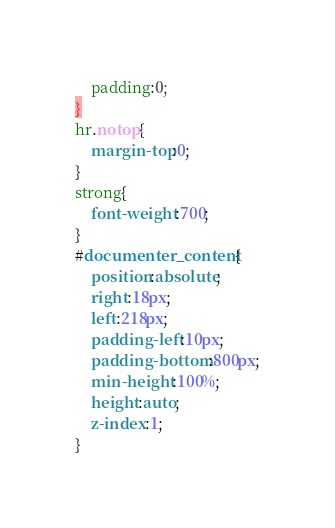Convert code to text. <code><loc_0><loc_0><loc_500><loc_500><_CSS_>	padding:0;
}
hr.notop{
	margin-top:0;
}
strong{
	font-weight:700;
}
#documenter_content{
	position:absolute;
	right:18px;
	left:218px;
	padding-left:10px;
	padding-bottom:800px;
	min-height:100%;
	height:auto;
	z-index:1;
}</code> 